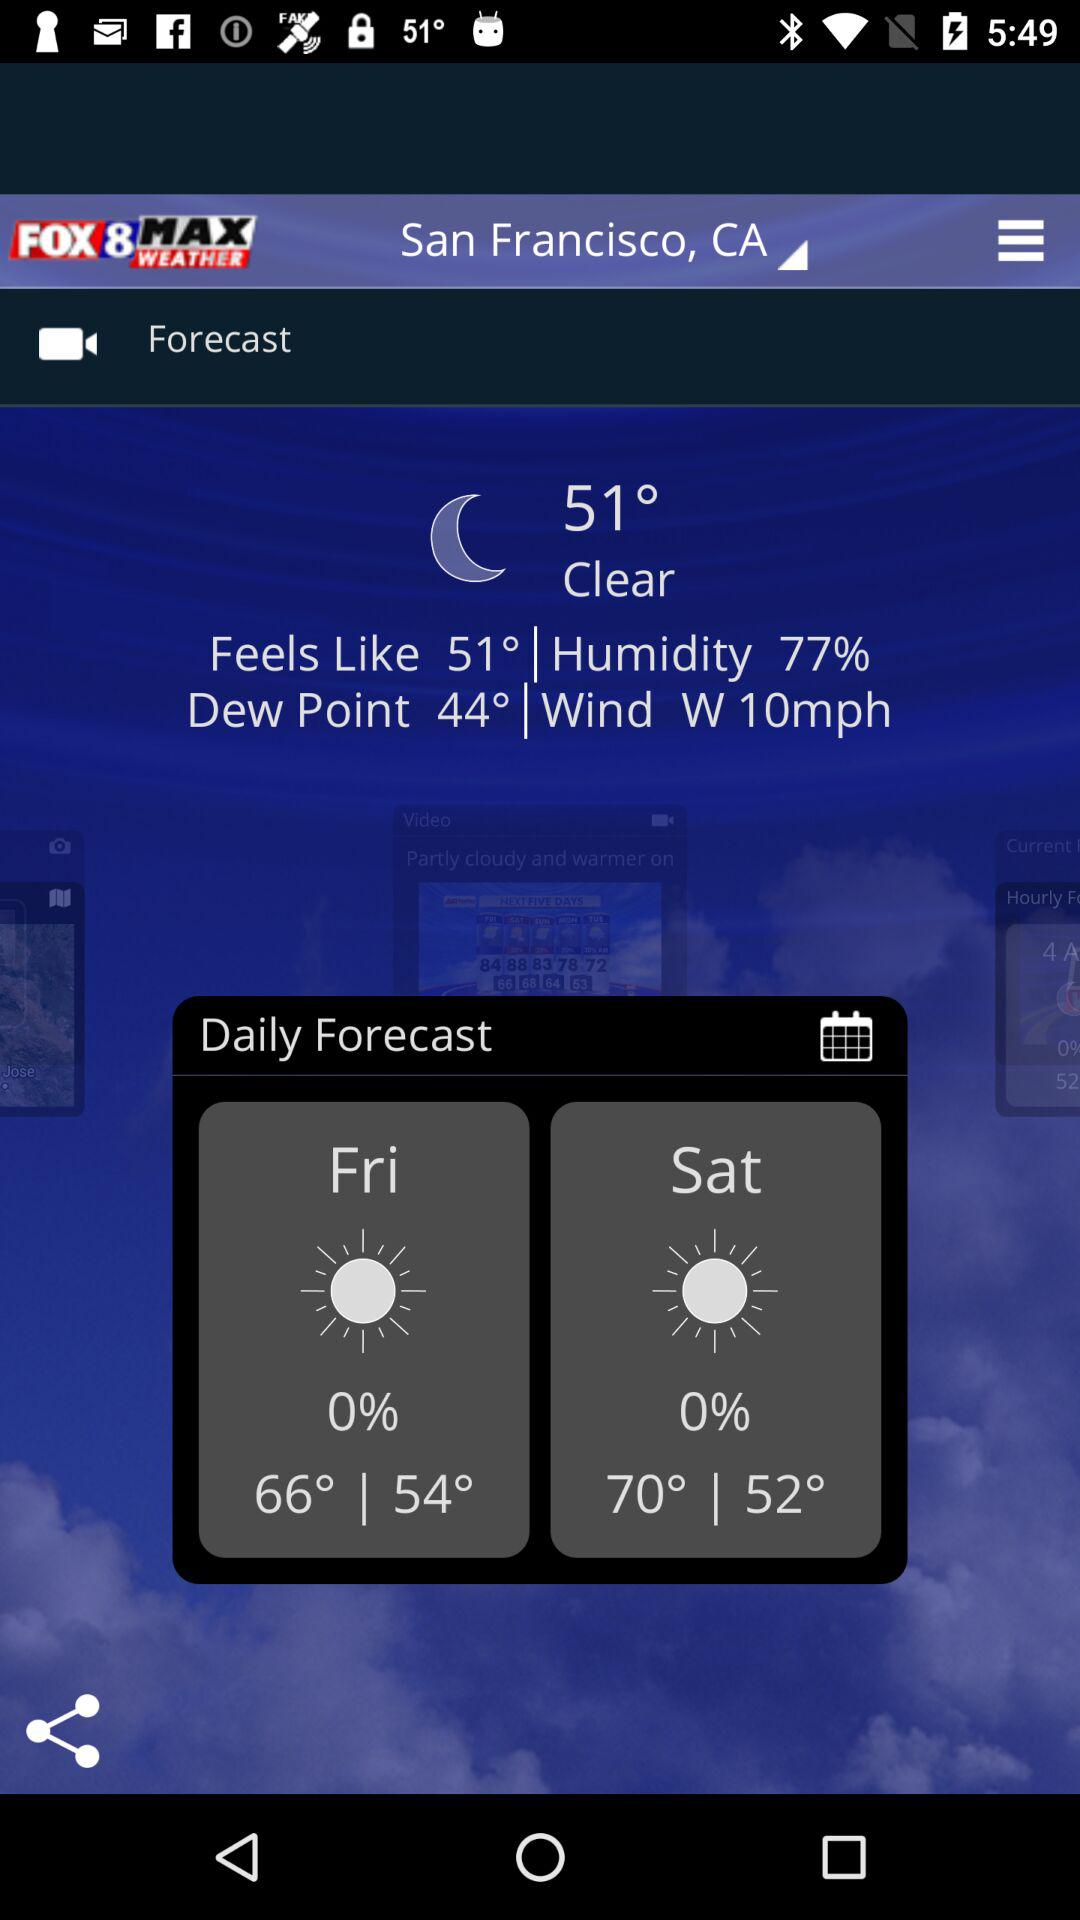What temperature is the dew point measured at? The dew point is measured at 51°. 